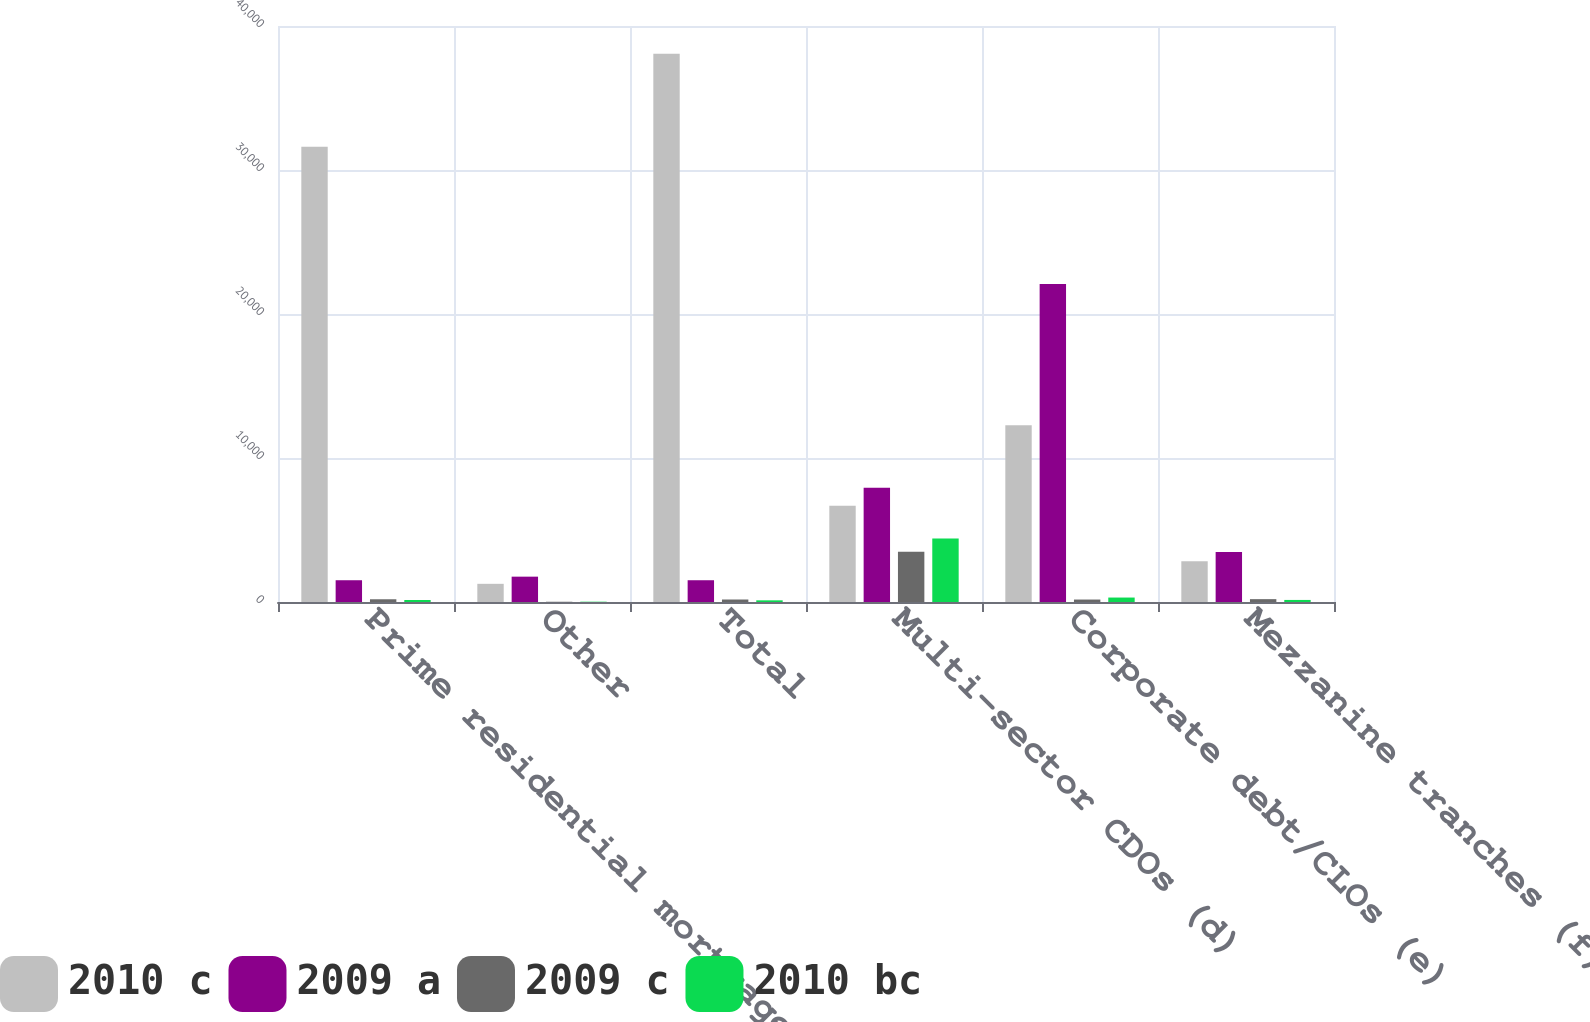Convert chart to OTSL. <chart><loc_0><loc_0><loc_500><loc_500><stacked_bar_chart><ecel><fcel>Prime residential mortgages<fcel>Other<fcel>Total<fcel>Multi-sector CDOs (d)<fcel>Corporate debt/CLOs (e)<fcel>Mezzanine tranches (f)<nl><fcel>2010 c<fcel>31613<fcel>1263<fcel>38069<fcel>6689<fcel>12269<fcel>2823<nl><fcel>2009 a<fcel>1511.5<fcel>1760<fcel>1511.5<fcel>7926<fcel>22076<fcel>3478<nl><fcel>2009 c<fcel>190<fcel>17<fcel>173<fcel>3484<fcel>171<fcel>198<nl><fcel>2010 bc<fcel>137<fcel>21<fcel>116<fcel>4418<fcel>309<fcel>143<nl></chart> 